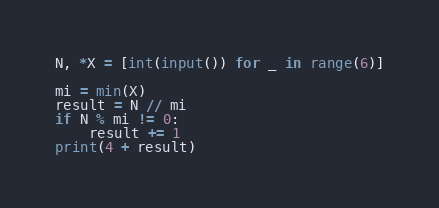Convert code to text. <code><loc_0><loc_0><loc_500><loc_500><_Python_>N, *X = [int(input()) for _ in range(6)]

mi = min(X)
result = N // mi
if N % mi != 0:
    result += 1
print(4 + result)
</code> 